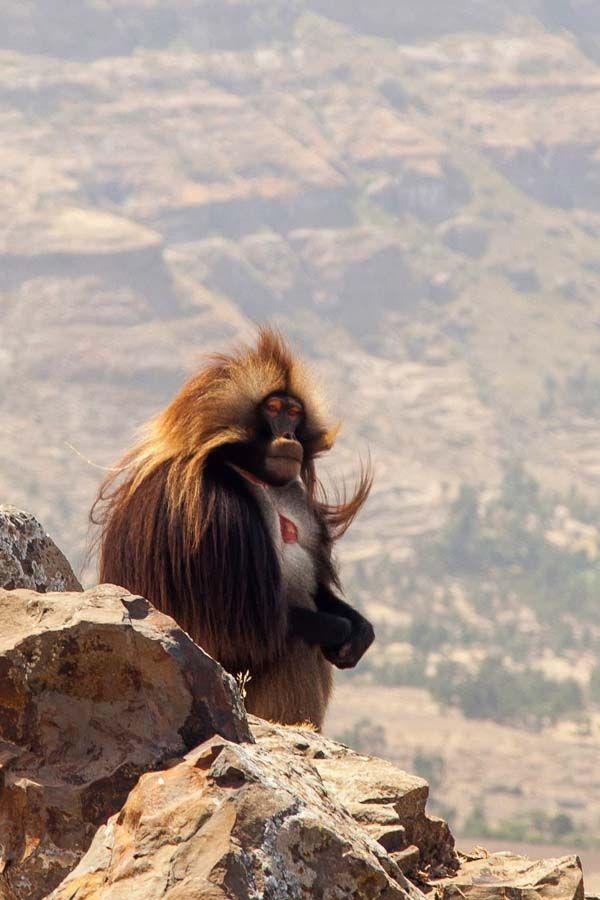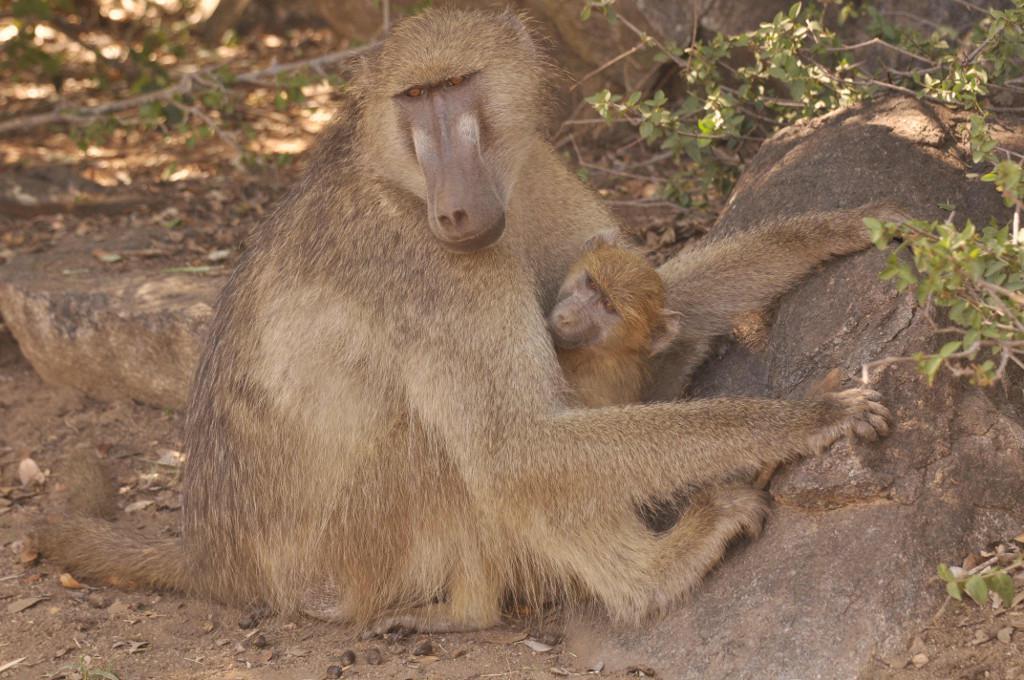The first image is the image on the left, the second image is the image on the right. For the images shown, is this caption "Each image shows two animals interacting, and one image shows a monkey grooming the animal next to it." true? Answer yes or no. No. The first image is the image on the left, the second image is the image on the right. Analyze the images presented: Is the assertion "There are exactly three apes." valid? Answer yes or no. Yes. 